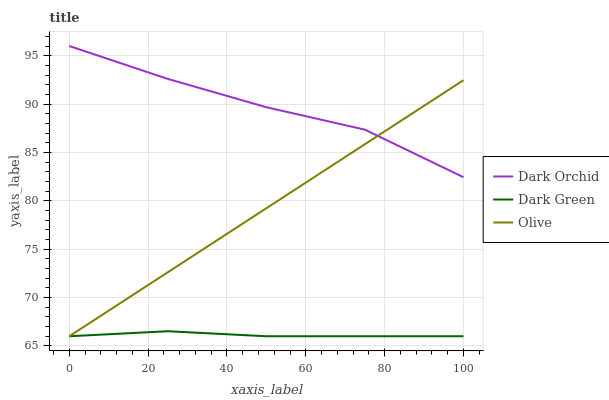Does Dark Green have the minimum area under the curve?
Answer yes or no. Yes. Does Dark Orchid have the maximum area under the curve?
Answer yes or no. Yes. Does Dark Orchid have the minimum area under the curve?
Answer yes or no. No. Does Dark Green have the maximum area under the curve?
Answer yes or no. No. Is Olive the smoothest?
Answer yes or no. Yes. Is Dark Orchid the roughest?
Answer yes or no. Yes. Is Dark Green the smoothest?
Answer yes or no. No. Is Dark Green the roughest?
Answer yes or no. No. Does Olive have the lowest value?
Answer yes or no. Yes. Does Dark Orchid have the lowest value?
Answer yes or no. No. Does Dark Orchid have the highest value?
Answer yes or no. Yes. Does Dark Green have the highest value?
Answer yes or no. No. Is Dark Green less than Dark Orchid?
Answer yes or no. Yes. Is Dark Orchid greater than Dark Green?
Answer yes or no. Yes. Does Dark Green intersect Olive?
Answer yes or no. Yes. Is Dark Green less than Olive?
Answer yes or no. No. Is Dark Green greater than Olive?
Answer yes or no. No. Does Dark Green intersect Dark Orchid?
Answer yes or no. No. 